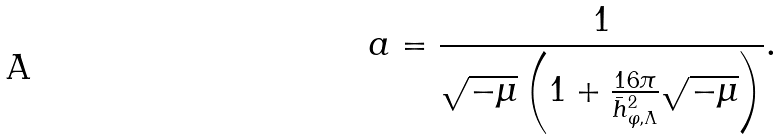<formula> <loc_0><loc_0><loc_500><loc_500>a = \frac { 1 } { \sqrt { - \mu } \left ( 1 + \frac { 1 6 \pi } { \bar { h } _ { \varphi , \Lambda } ^ { 2 } } \sqrt { - \mu } \right ) } .</formula> 